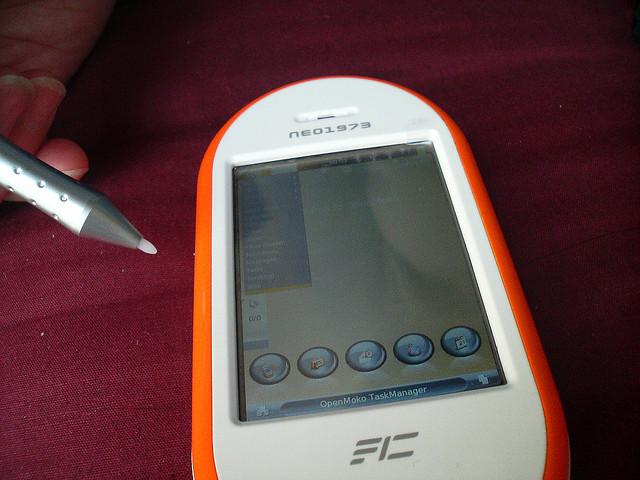What is the person holding in their hand?
Concise answer only. Stylus. Is device turned on?
Quick response, please. Yes. Is the phone working?
Keep it brief. Yes. What is this device?
Short answer required. Cell phone. 